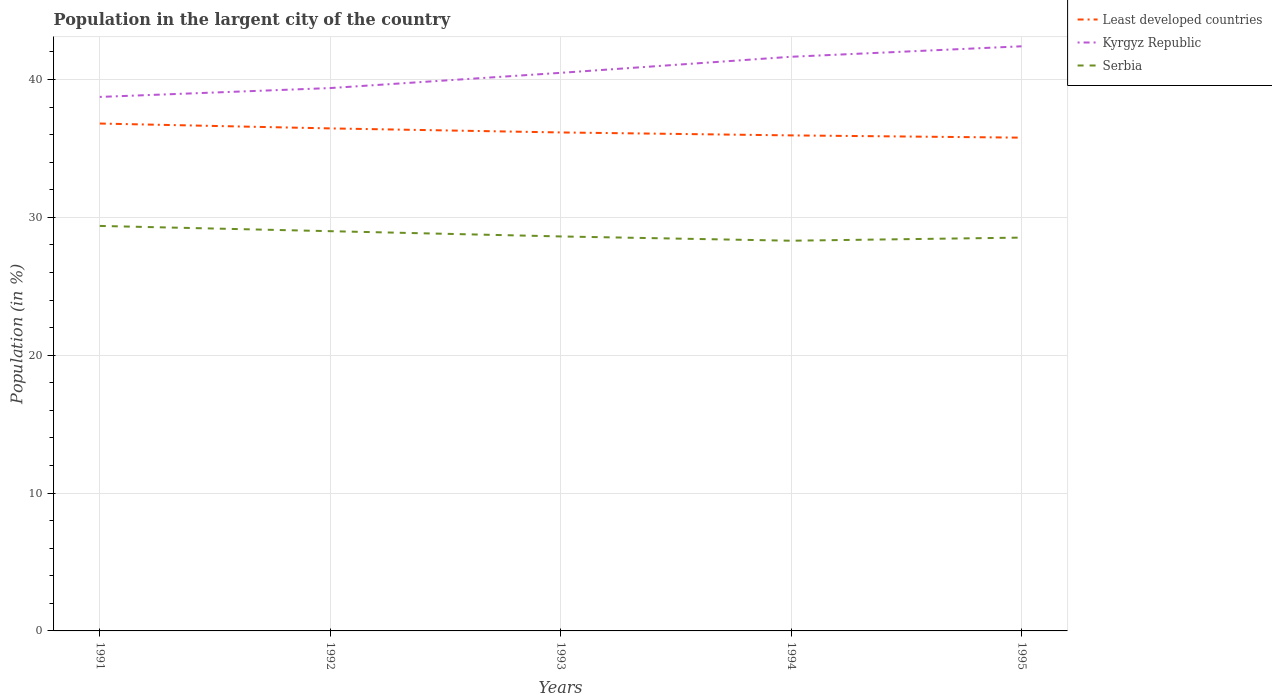How many different coloured lines are there?
Make the answer very short. 3. Does the line corresponding to Least developed countries intersect with the line corresponding to Kyrgyz Republic?
Offer a terse response. No. Is the number of lines equal to the number of legend labels?
Offer a very short reply. Yes. Across all years, what is the maximum percentage of population in the largent city in Serbia?
Give a very brief answer. 28.31. In which year was the percentage of population in the largent city in Least developed countries maximum?
Ensure brevity in your answer.  1995. What is the total percentage of population in the largent city in Kyrgyz Republic in the graph?
Your answer should be compact. -2.27. What is the difference between the highest and the second highest percentage of population in the largent city in Least developed countries?
Ensure brevity in your answer.  1.02. What is the difference between the highest and the lowest percentage of population in the largent city in Serbia?
Your answer should be compact. 2. Is the percentage of population in the largent city in Kyrgyz Republic strictly greater than the percentage of population in the largent city in Serbia over the years?
Give a very brief answer. No. What is the difference between two consecutive major ticks on the Y-axis?
Offer a very short reply. 10. What is the title of the graph?
Your answer should be very brief. Population in the largent city of the country. What is the label or title of the X-axis?
Provide a succinct answer. Years. What is the label or title of the Y-axis?
Provide a short and direct response. Population (in %). What is the Population (in %) of Least developed countries in 1991?
Provide a short and direct response. 36.81. What is the Population (in %) in Kyrgyz Republic in 1991?
Offer a terse response. 38.74. What is the Population (in %) in Serbia in 1991?
Give a very brief answer. 29.38. What is the Population (in %) in Least developed countries in 1992?
Keep it short and to the point. 36.45. What is the Population (in %) of Kyrgyz Republic in 1992?
Give a very brief answer. 39.38. What is the Population (in %) in Serbia in 1992?
Offer a terse response. 29. What is the Population (in %) of Least developed countries in 1993?
Make the answer very short. 36.16. What is the Population (in %) of Kyrgyz Republic in 1993?
Keep it short and to the point. 40.48. What is the Population (in %) in Serbia in 1993?
Your answer should be very brief. 28.62. What is the Population (in %) in Least developed countries in 1994?
Give a very brief answer. 35.95. What is the Population (in %) in Kyrgyz Republic in 1994?
Your response must be concise. 41.65. What is the Population (in %) in Serbia in 1994?
Make the answer very short. 28.31. What is the Population (in %) of Least developed countries in 1995?
Your response must be concise. 35.78. What is the Population (in %) of Kyrgyz Republic in 1995?
Your answer should be compact. 42.41. What is the Population (in %) of Serbia in 1995?
Keep it short and to the point. 28.53. Across all years, what is the maximum Population (in %) in Least developed countries?
Your answer should be compact. 36.81. Across all years, what is the maximum Population (in %) in Kyrgyz Republic?
Keep it short and to the point. 42.41. Across all years, what is the maximum Population (in %) in Serbia?
Keep it short and to the point. 29.38. Across all years, what is the minimum Population (in %) of Least developed countries?
Make the answer very short. 35.78. Across all years, what is the minimum Population (in %) in Kyrgyz Republic?
Ensure brevity in your answer.  38.74. Across all years, what is the minimum Population (in %) of Serbia?
Provide a short and direct response. 28.31. What is the total Population (in %) of Least developed countries in the graph?
Give a very brief answer. 181.14. What is the total Population (in %) of Kyrgyz Republic in the graph?
Give a very brief answer. 202.65. What is the total Population (in %) of Serbia in the graph?
Offer a very short reply. 143.83. What is the difference between the Population (in %) in Least developed countries in 1991 and that in 1992?
Your answer should be compact. 0.35. What is the difference between the Population (in %) in Kyrgyz Republic in 1991 and that in 1992?
Your response must be concise. -0.64. What is the difference between the Population (in %) in Serbia in 1991 and that in 1992?
Provide a short and direct response. 0.38. What is the difference between the Population (in %) of Least developed countries in 1991 and that in 1993?
Keep it short and to the point. 0.65. What is the difference between the Population (in %) in Kyrgyz Republic in 1991 and that in 1993?
Offer a very short reply. -1.75. What is the difference between the Population (in %) in Serbia in 1991 and that in 1993?
Give a very brief answer. 0.76. What is the difference between the Population (in %) of Least developed countries in 1991 and that in 1994?
Make the answer very short. 0.86. What is the difference between the Population (in %) of Kyrgyz Republic in 1991 and that in 1994?
Offer a very short reply. -2.91. What is the difference between the Population (in %) in Serbia in 1991 and that in 1994?
Your answer should be very brief. 1.07. What is the difference between the Population (in %) of Least developed countries in 1991 and that in 1995?
Your response must be concise. 1.02. What is the difference between the Population (in %) in Kyrgyz Republic in 1991 and that in 1995?
Give a very brief answer. -3.67. What is the difference between the Population (in %) in Serbia in 1991 and that in 1995?
Make the answer very short. 0.85. What is the difference between the Population (in %) of Least developed countries in 1992 and that in 1993?
Keep it short and to the point. 0.29. What is the difference between the Population (in %) in Kyrgyz Republic in 1992 and that in 1993?
Make the answer very short. -1.1. What is the difference between the Population (in %) in Serbia in 1992 and that in 1993?
Give a very brief answer. 0.38. What is the difference between the Population (in %) of Least developed countries in 1992 and that in 1994?
Your answer should be very brief. 0.51. What is the difference between the Population (in %) of Kyrgyz Republic in 1992 and that in 1994?
Your answer should be compact. -2.27. What is the difference between the Population (in %) in Serbia in 1992 and that in 1994?
Your response must be concise. 0.69. What is the difference between the Population (in %) of Least developed countries in 1992 and that in 1995?
Offer a terse response. 0.67. What is the difference between the Population (in %) of Kyrgyz Republic in 1992 and that in 1995?
Your response must be concise. -3.03. What is the difference between the Population (in %) of Serbia in 1992 and that in 1995?
Make the answer very short. 0.47. What is the difference between the Population (in %) in Least developed countries in 1993 and that in 1994?
Provide a succinct answer. 0.21. What is the difference between the Population (in %) in Kyrgyz Republic in 1993 and that in 1994?
Offer a very short reply. -1.17. What is the difference between the Population (in %) in Serbia in 1993 and that in 1994?
Your response must be concise. 0.31. What is the difference between the Population (in %) in Least developed countries in 1993 and that in 1995?
Your answer should be compact. 0.38. What is the difference between the Population (in %) of Kyrgyz Republic in 1993 and that in 1995?
Give a very brief answer. -1.93. What is the difference between the Population (in %) in Serbia in 1993 and that in 1995?
Keep it short and to the point. 0.08. What is the difference between the Population (in %) of Least developed countries in 1994 and that in 1995?
Keep it short and to the point. 0.16. What is the difference between the Population (in %) in Kyrgyz Republic in 1994 and that in 1995?
Make the answer very short. -0.76. What is the difference between the Population (in %) of Serbia in 1994 and that in 1995?
Your response must be concise. -0.23. What is the difference between the Population (in %) in Least developed countries in 1991 and the Population (in %) in Kyrgyz Republic in 1992?
Your response must be concise. -2.57. What is the difference between the Population (in %) in Least developed countries in 1991 and the Population (in %) in Serbia in 1992?
Your answer should be compact. 7.81. What is the difference between the Population (in %) in Kyrgyz Republic in 1991 and the Population (in %) in Serbia in 1992?
Offer a terse response. 9.74. What is the difference between the Population (in %) of Least developed countries in 1991 and the Population (in %) of Kyrgyz Republic in 1993?
Ensure brevity in your answer.  -3.68. What is the difference between the Population (in %) of Least developed countries in 1991 and the Population (in %) of Serbia in 1993?
Your answer should be compact. 8.19. What is the difference between the Population (in %) in Kyrgyz Republic in 1991 and the Population (in %) in Serbia in 1993?
Provide a short and direct response. 10.12. What is the difference between the Population (in %) of Least developed countries in 1991 and the Population (in %) of Kyrgyz Republic in 1994?
Make the answer very short. -4.84. What is the difference between the Population (in %) in Least developed countries in 1991 and the Population (in %) in Serbia in 1994?
Keep it short and to the point. 8.5. What is the difference between the Population (in %) in Kyrgyz Republic in 1991 and the Population (in %) in Serbia in 1994?
Your answer should be very brief. 10.43. What is the difference between the Population (in %) of Least developed countries in 1991 and the Population (in %) of Kyrgyz Republic in 1995?
Offer a very short reply. -5.6. What is the difference between the Population (in %) of Least developed countries in 1991 and the Population (in %) of Serbia in 1995?
Keep it short and to the point. 8.27. What is the difference between the Population (in %) in Kyrgyz Republic in 1991 and the Population (in %) in Serbia in 1995?
Offer a terse response. 10.2. What is the difference between the Population (in %) in Least developed countries in 1992 and the Population (in %) in Kyrgyz Republic in 1993?
Provide a short and direct response. -4.03. What is the difference between the Population (in %) of Least developed countries in 1992 and the Population (in %) of Serbia in 1993?
Give a very brief answer. 7.84. What is the difference between the Population (in %) in Kyrgyz Republic in 1992 and the Population (in %) in Serbia in 1993?
Ensure brevity in your answer.  10.76. What is the difference between the Population (in %) of Least developed countries in 1992 and the Population (in %) of Kyrgyz Republic in 1994?
Offer a very short reply. -5.2. What is the difference between the Population (in %) of Least developed countries in 1992 and the Population (in %) of Serbia in 1994?
Ensure brevity in your answer.  8.15. What is the difference between the Population (in %) of Kyrgyz Republic in 1992 and the Population (in %) of Serbia in 1994?
Provide a short and direct response. 11.07. What is the difference between the Population (in %) of Least developed countries in 1992 and the Population (in %) of Kyrgyz Republic in 1995?
Your answer should be very brief. -5.96. What is the difference between the Population (in %) of Least developed countries in 1992 and the Population (in %) of Serbia in 1995?
Provide a succinct answer. 7.92. What is the difference between the Population (in %) in Kyrgyz Republic in 1992 and the Population (in %) in Serbia in 1995?
Provide a short and direct response. 10.85. What is the difference between the Population (in %) in Least developed countries in 1993 and the Population (in %) in Kyrgyz Republic in 1994?
Give a very brief answer. -5.49. What is the difference between the Population (in %) of Least developed countries in 1993 and the Population (in %) of Serbia in 1994?
Provide a short and direct response. 7.85. What is the difference between the Population (in %) in Kyrgyz Republic in 1993 and the Population (in %) in Serbia in 1994?
Offer a terse response. 12.18. What is the difference between the Population (in %) of Least developed countries in 1993 and the Population (in %) of Kyrgyz Republic in 1995?
Provide a succinct answer. -6.25. What is the difference between the Population (in %) of Least developed countries in 1993 and the Population (in %) of Serbia in 1995?
Provide a succinct answer. 7.63. What is the difference between the Population (in %) of Kyrgyz Republic in 1993 and the Population (in %) of Serbia in 1995?
Provide a succinct answer. 11.95. What is the difference between the Population (in %) in Least developed countries in 1994 and the Population (in %) in Kyrgyz Republic in 1995?
Your answer should be compact. -6.46. What is the difference between the Population (in %) in Least developed countries in 1994 and the Population (in %) in Serbia in 1995?
Provide a succinct answer. 7.41. What is the difference between the Population (in %) of Kyrgyz Republic in 1994 and the Population (in %) of Serbia in 1995?
Ensure brevity in your answer.  13.12. What is the average Population (in %) of Least developed countries per year?
Ensure brevity in your answer.  36.23. What is the average Population (in %) in Kyrgyz Republic per year?
Provide a short and direct response. 40.53. What is the average Population (in %) of Serbia per year?
Provide a succinct answer. 28.77. In the year 1991, what is the difference between the Population (in %) in Least developed countries and Population (in %) in Kyrgyz Republic?
Provide a short and direct response. -1.93. In the year 1991, what is the difference between the Population (in %) of Least developed countries and Population (in %) of Serbia?
Your answer should be compact. 7.43. In the year 1991, what is the difference between the Population (in %) of Kyrgyz Republic and Population (in %) of Serbia?
Offer a terse response. 9.36. In the year 1992, what is the difference between the Population (in %) of Least developed countries and Population (in %) of Kyrgyz Republic?
Give a very brief answer. -2.93. In the year 1992, what is the difference between the Population (in %) in Least developed countries and Population (in %) in Serbia?
Provide a succinct answer. 7.46. In the year 1992, what is the difference between the Population (in %) in Kyrgyz Republic and Population (in %) in Serbia?
Keep it short and to the point. 10.38. In the year 1993, what is the difference between the Population (in %) in Least developed countries and Population (in %) in Kyrgyz Republic?
Give a very brief answer. -4.32. In the year 1993, what is the difference between the Population (in %) in Least developed countries and Population (in %) in Serbia?
Your answer should be very brief. 7.54. In the year 1993, what is the difference between the Population (in %) in Kyrgyz Republic and Population (in %) in Serbia?
Your answer should be very brief. 11.87. In the year 1994, what is the difference between the Population (in %) in Least developed countries and Population (in %) in Kyrgyz Republic?
Your response must be concise. -5.7. In the year 1994, what is the difference between the Population (in %) of Least developed countries and Population (in %) of Serbia?
Provide a short and direct response. 7.64. In the year 1994, what is the difference between the Population (in %) in Kyrgyz Republic and Population (in %) in Serbia?
Your response must be concise. 13.34. In the year 1995, what is the difference between the Population (in %) of Least developed countries and Population (in %) of Kyrgyz Republic?
Provide a succinct answer. -6.63. In the year 1995, what is the difference between the Population (in %) in Least developed countries and Population (in %) in Serbia?
Provide a succinct answer. 7.25. In the year 1995, what is the difference between the Population (in %) in Kyrgyz Republic and Population (in %) in Serbia?
Your answer should be very brief. 13.88. What is the ratio of the Population (in %) in Least developed countries in 1991 to that in 1992?
Provide a short and direct response. 1.01. What is the ratio of the Population (in %) in Kyrgyz Republic in 1991 to that in 1992?
Keep it short and to the point. 0.98. What is the ratio of the Population (in %) in Serbia in 1991 to that in 1992?
Keep it short and to the point. 1.01. What is the ratio of the Population (in %) of Least developed countries in 1991 to that in 1993?
Your answer should be compact. 1.02. What is the ratio of the Population (in %) in Kyrgyz Republic in 1991 to that in 1993?
Ensure brevity in your answer.  0.96. What is the ratio of the Population (in %) in Serbia in 1991 to that in 1993?
Keep it short and to the point. 1.03. What is the ratio of the Population (in %) of Least developed countries in 1991 to that in 1994?
Keep it short and to the point. 1.02. What is the ratio of the Population (in %) of Kyrgyz Republic in 1991 to that in 1994?
Give a very brief answer. 0.93. What is the ratio of the Population (in %) in Serbia in 1991 to that in 1994?
Your answer should be compact. 1.04. What is the ratio of the Population (in %) in Least developed countries in 1991 to that in 1995?
Your response must be concise. 1.03. What is the ratio of the Population (in %) in Kyrgyz Republic in 1991 to that in 1995?
Keep it short and to the point. 0.91. What is the ratio of the Population (in %) in Serbia in 1991 to that in 1995?
Your response must be concise. 1.03. What is the ratio of the Population (in %) in Kyrgyz Republic in 1992 to that in 1993?
Ensure brevity in your answer.  0.97. What is the ratio of the Population (in %) in Serbia in 1992 to that in 1993?
Your answer should be compact. 1.01. What is the ratio of the Population (in %) of Least developed countries in 1992 to that in 1994?
Offer a very short reply. 1.01. What is the ratio of the Population (in %) of Kyrgyz Republic in 1992 to that in 1994?
Ensure brevity in your answer.  0.95. What is the ratio of the Population (in %) in Serbia in 1992 to that in 1994?
Provide a short and direct response. 1.02. What is the ratio of the Population (in %) in Least developed countries in 1992 to that in 1995?
Ensure brevity in your answer.  1.02. What is the ratio of the Population (in %) in Serbia in 1992 to that in 1995?
Provide a succinct answer. 1.02. What is the ratio of the Population (in %) of Least developed countries in 1993 to that in 1994?
Keep it short and to the point. 1.01. What is the ratio of the Population (in %) in Kyrgyz Republic in 1993 to that in 1994?
Offer a very short reply. 0.97. What is the ratio of the Population (in %) of Least developed countries in 1993 to that in 1995?
Provide a short and direct response. 1.01. What is the ratio of the Population (in %) of Kyrgyz Republic in 1993 to that in 1995?
Your answer should be compact. 0.95. What is the ratio of the Population (in %) in Least developed countries in 1994 to that in 1995?
Make the answer very short. 1. What is the ratio of the Population (in %) of Kyrgyz Republic in 1994 to that in 1995?
Provide a short and direct response. 0.98. What is the difference between the highest and the second highest Population (in %) in Least developed countries?
Your answer should be very brief. 0.35. What is the difference between the highest and the second highest Population (in %) in Kyrgyz Republic?
Provide a succinct answer. 0.76. What is the difference between the highest and the second highest Population (in %) of Serbia?
Your answer should be compact. 0.38. What is the difference between the highest and the lowest Population (in %) in Least developed countries?
Provide a succinct answer. 1.02. What is the difference between the highest and the lowest Population (in %) of Kyrgyz Republic?
Give a very brief answer. 3.67. What is the difference between the highest and the lowest Population (in %) of Serbia?
Keep it short and to the point. 1.07. 